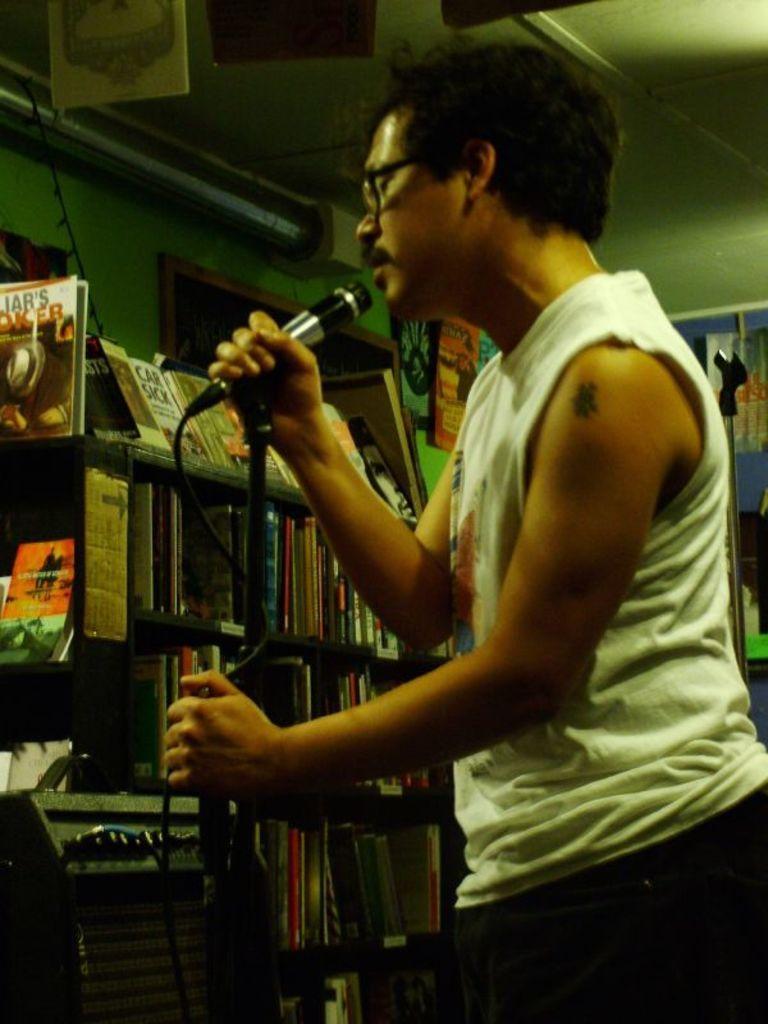Could you give a brief overview of what you see in this image? A man with white shirt is holding a mic stand in his hands. To the left side there is a cupboard with many books in it. And to the top left corner there is an object with silver color. 